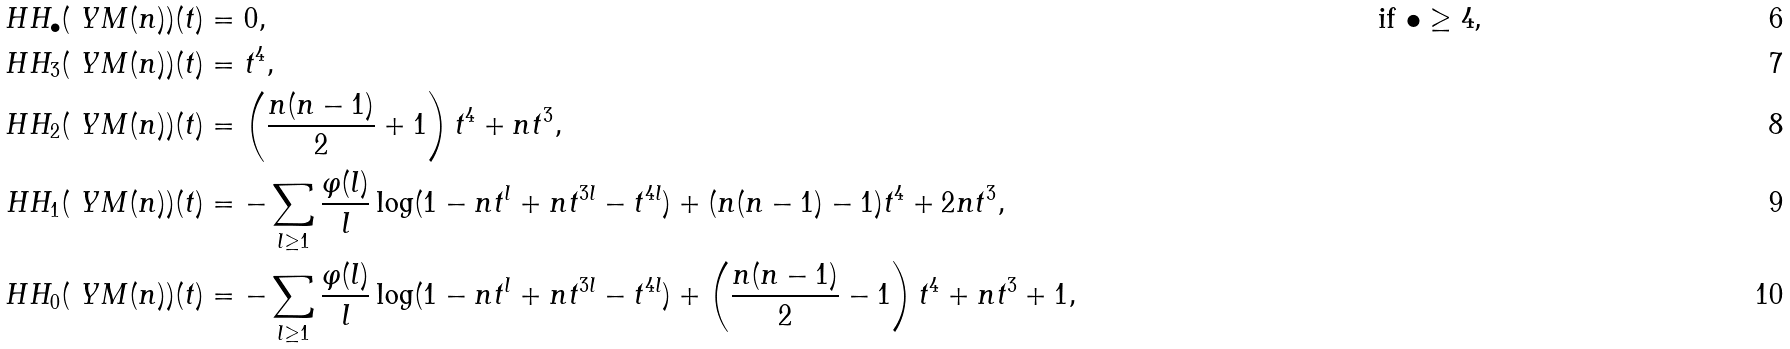<formula> <loc_0><loc_0><loc_500><loc_500>H H _ { \bullet } ( \ Y M ( n ) ) ( t ) & = 0 , & \text {if $\bullet \geq 4$,} \\ H H _ { 3 } ( \ Y M ( n ) ) ( t ) & = t ^ { 4 } , \\ H H _ { 2 } ( \ Y M ( n ) ) ( t ) & = \left ( \frac { n ( n - 1 ) } { 2 } + 1 \right ) t ^ { 4 } + n t ^ { 3 } , \\ H H _ { 1 } ( \ Y M ( n ) ) ( t ) & = - \sum _ { l \geq 1 } \frac { \varphi ( l ) } { l } \log ( 1 - n t ^ { l } + n t ^ { 3 l } - t ^ { 4 l } ) + ( n ( n - 1 ) - 1 ) t ^ { 4 } + 2 n t ^ { 3 } , \\ H H _ { 0 } ( \ Y M ( n ) ) ( t ) & = - \sum _ { l \geq 1 } \frac { \varphi ( l ) } { l } \log ( 1 - n t ^ { l } + n t ^ { 3 l } - t ^ { 4 l } ) + \left ( \frac { n ( n - 1 ) } { 2 } - 1 \right ) t ^ { 4 } + n t ^ { 3 } + 1 ,</formula> 